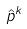Convert formula to latex. <formula><loc_0><loc_0><loc_500><loc_500>\hat { p } ^ { k }</formula> 